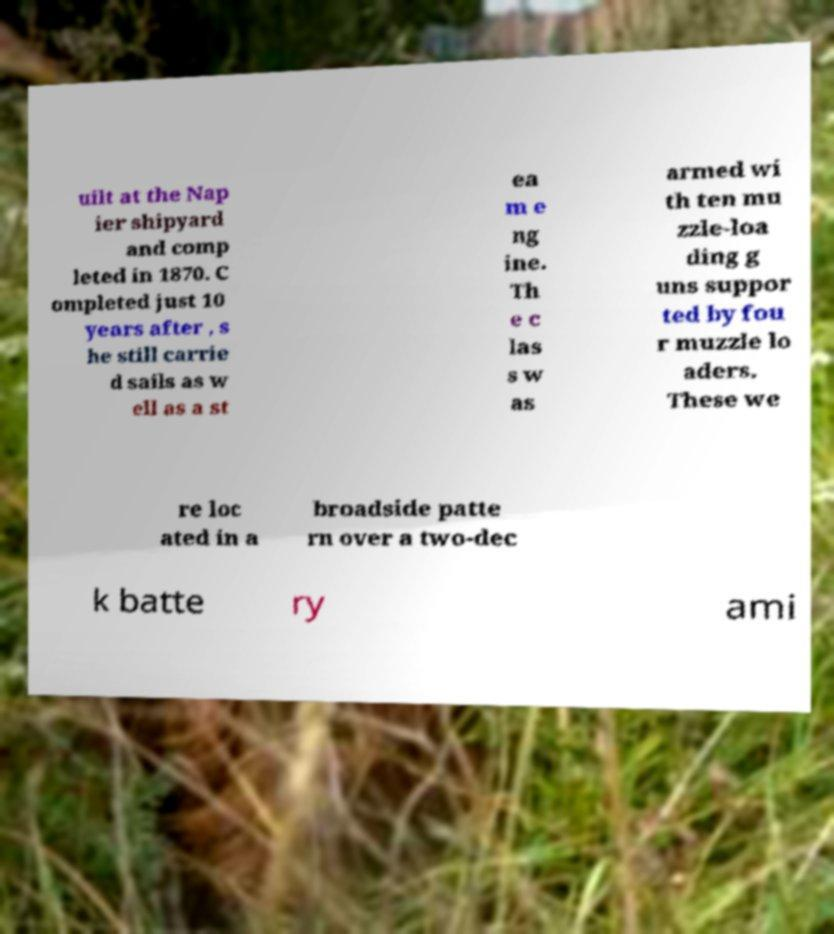What messages or text are displayed in this image? I need them in a readable, typed format. uilt at the Nap ier shipyard and comp leted in 1870. C ompleted just 10 years after , s he still carrie d sails as w ell as a st ea m e ng ine. Th e c las s w as armed wi th ten mu zzle-loa ding g uns suppor ted by fou r muzzle lo aders. These we re loc ated in a broadside patte rn over a two-dec k batte ry ami 